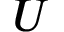Convert formula to latex. <formula><loc_0><loc_0><loc_500><loc_500>U</formula> 